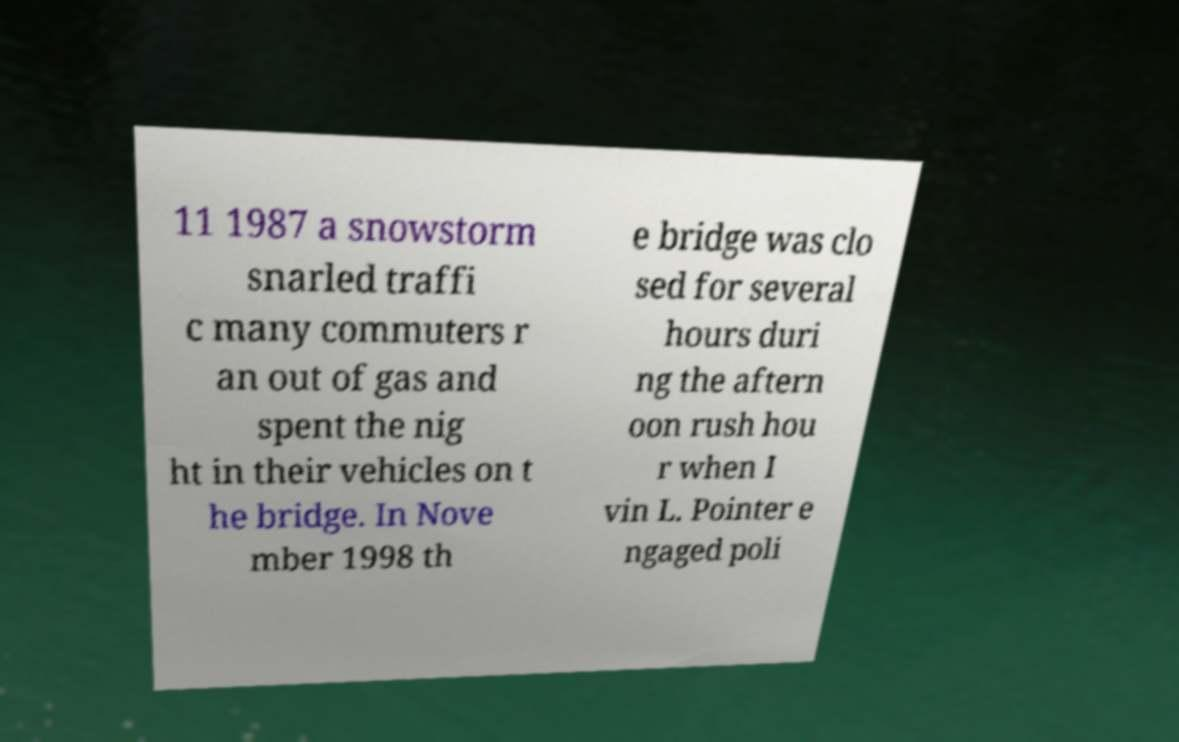For documentation purposes, I need the text within this image transcribed. Could you provide that? 11 1987 a snowstorm snarled traffi c many commuters r an out of gas and spent the nig ht in their vehicles on t he bridge. In Nove mber 1998 th e bridge was clo sed for several hours duri ng the aftern oon rush hou r when I vin L. Pointer e ngaged poli 